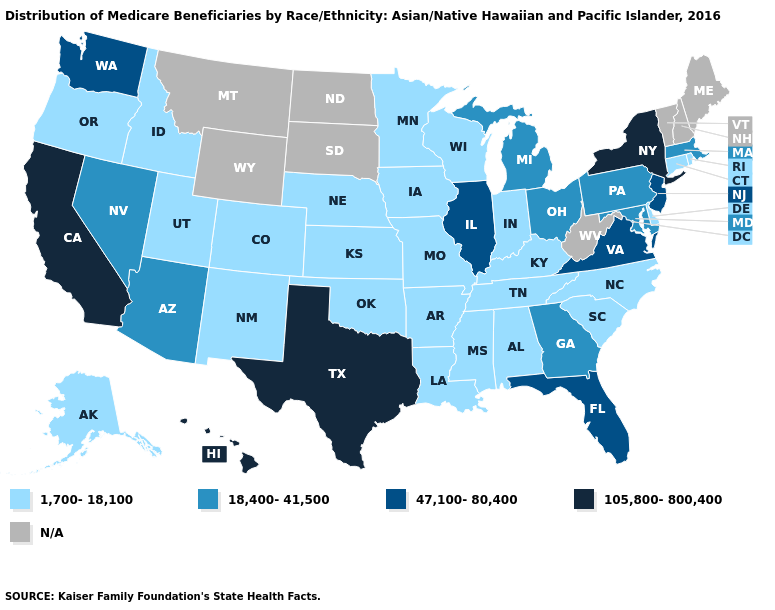Name the states that have a value in the range 18,400-41,500?
Concise answer only. Arizona, Georgia, Maryland, Massachusetts, Michigan, Nevada, Ohio, Pennsylvania. What is the value of New Jersey?
Quick response, please. 47,100-80,400. Name the states that have a value in the range 1,700-18,100?
Answer briefly. Alabama, Alaska, Arkansas, Colorado, Connecticut, Delaware, Idaho, Indiana, Iowa, Kansas, Kentucky, Louisiana, Minnesota, Mississippi, Missouri, Nebraska, New Mexico, North Carolina, Oklahoma, Oregon, Rhode Island, South Carolina, Tennessee, Utah, Wisconsin. Among the states that border Delaware , does New Jersey have the highest value?
Short answer required. Yes. Which states have the lowest value in the USA?
Give a very brief answer. Alabama, Alaska, Arkansas, Colorado, Connecticut, Delaware, Idaho, Indiana, Iowa, Kansas, Kentucky, Louisiana, Minnesota, Mississippi, Missouri, Nebraska, New Mexico, North Carolina, Oklahoma, Oregon, Rhode Island, South Carolina, Tennessee, Utah, Wisconsin. Name the states that have a value in the range N/A?
Write a very short answer. Maine, Montana, New Hampshire, North Dakota, South Dakota, Vermont, West Virginia, Wyoming. What is the lowest value in the Northeast?
Keep it brief. 1,700-18,100. Does the first symbol in the legend represent the smallest category?
Keep it brief. Yes. What is the highest value in the MidWest ?
Write a very short answer. 47,100-80,400. Does the first symbol in the legend represent the smallest category?
Quick response, please. Yes. Among the states that border Georgia , which have the lowest value?
Quick response, please. Alabama, North Carolina, South Carolina, Tennessee. Which states have the highest value in the USA?
Be succinct. California, Hawaii, New York, Texas. Which states have the lowest value in the MidWest?
Give a very brief answer. Indiana, Iowa, Kansas, Minnesota, Missouri, Nebraska, Wisconsin. Is the legend a continuous bar?
Write a very short answer. No. 